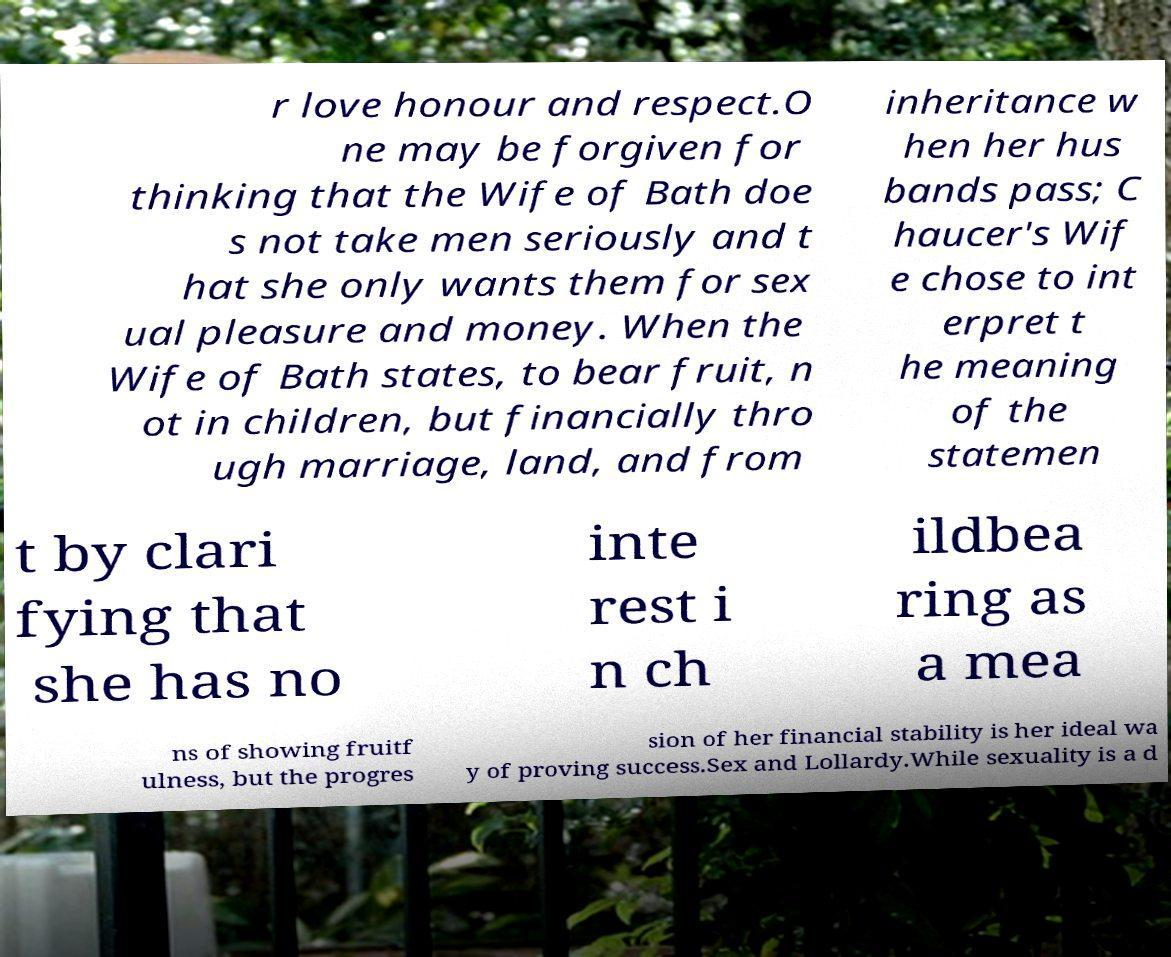What messages or text are displayed in this image? I need them in a readable, typed format. r love honour and respect.O ne may be forgiven for thinking that the Wife of Bath doe s not take men seriously and t hat she only wants them for sex ual pleasure and money. When the Wife of Bath states, to bear fruit, n ot in children, but financially thro ugh marriage, land, and from inheritance w hen her hus bands pass; C haucer's Wif e chose to int erpret t he meaning of the statemen t by clari fying that she has no inte rest i n ch ildbea ring as a mea ns of showing fruitf ulness, but the progres sion of her financial stability is her ideal wa y of proving success.Sex and Lollardy.While sexuality is a d 